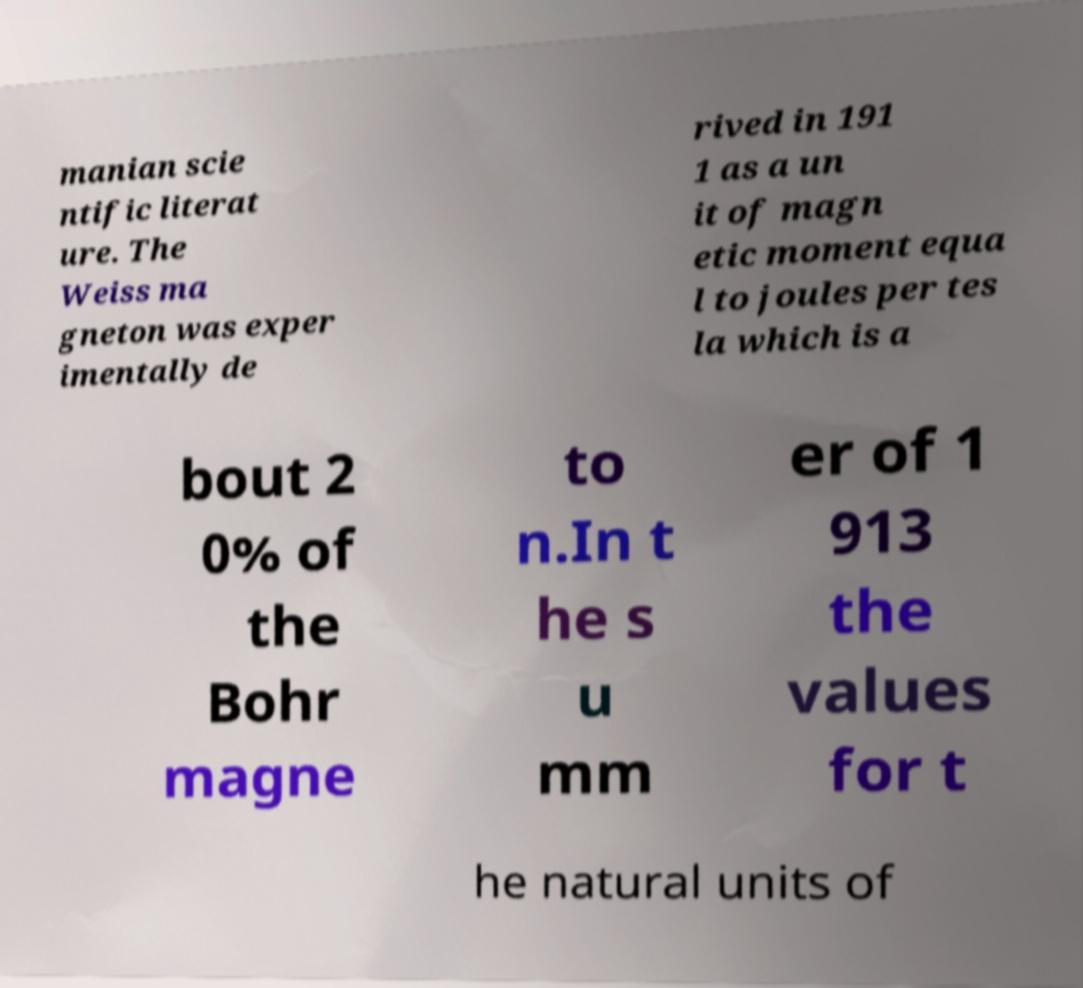What messages or text are displayed in this image? I need them in a readable, typed format. manian scie ntific literat ure. The Weiss ma gneton was exper imentally de rived in 191 1 as a un it of magn etic moment equa l to joules per tes la which is a bout 2 0% of the Bohr magne to n.In t he s u mm er of 1 913 the values for t he natural units of 